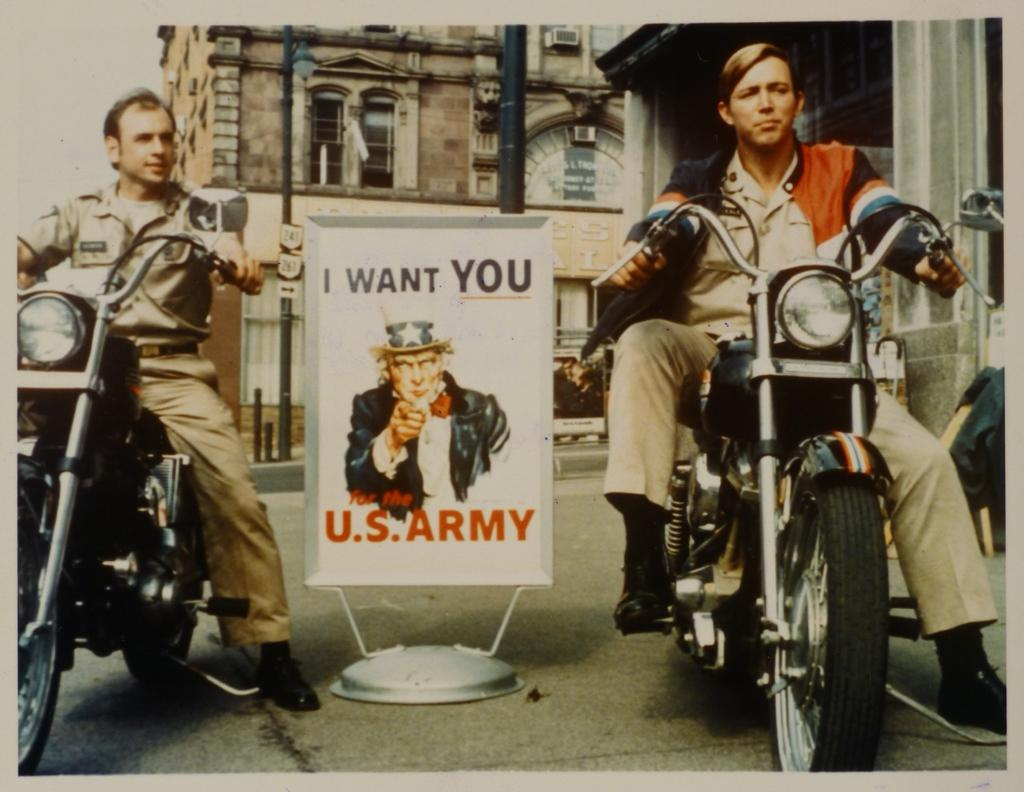How many people are in the image? There are two guys in the image. What are the guys doing in the image? The guys are sitting on a bike. What can be seen between the two guys? There is a poster named "I WANT YOU US ARMY" between the two guys. What is visible in the background of the image? There are buildings in the background of the image. What type of brain can be seen in the image? There is no brain present in the image. How does the wind affect the guys sitting on the bike in the image? The image does not show any wind or its effects on the guys sitting on the bike. 